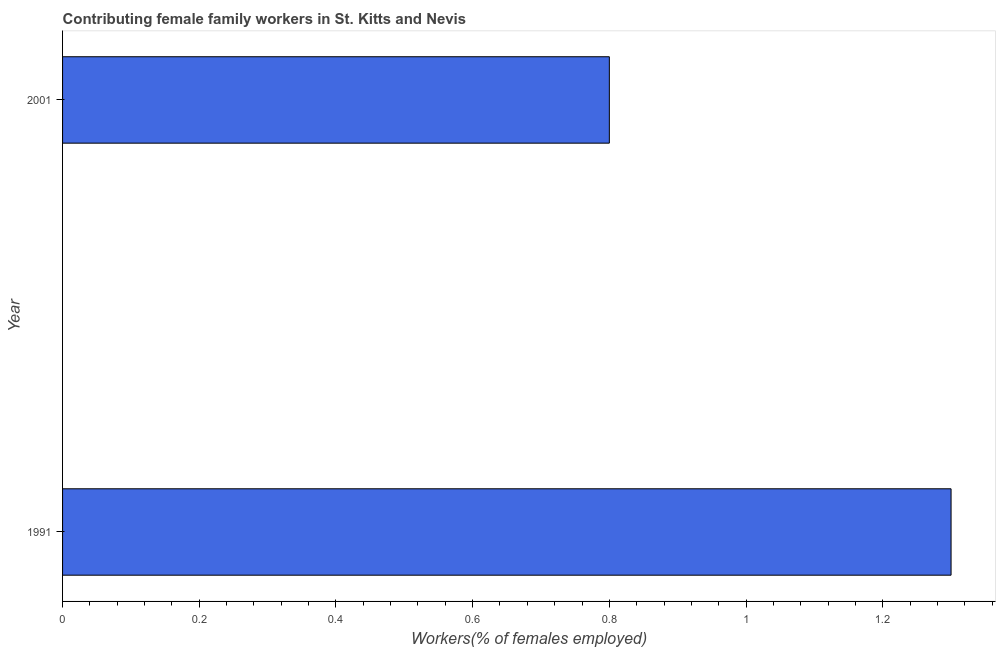Does the graph contain any zero values?
Provide a short and direct response. No. Does the graph contain grids?
Your answer should be very brief. No. What is the title of the graph?
Keep it short and to the point. Contributing female family workers in St. Kitts and Nevis. What is the label or title of the X-axis?
Your response must be concise. Workers(% of females employed). What is the contributing female family workers in 2001?
Your answer should be very brief. 0.8. Across all years, what is the maximum contributing female family workers?
Offer a very short reply. 1.3. Across all years, what is the minimum contributing female family workers?
Make the answer very short. 0.8. What is the sum of the contributing female family workers?
Provide a succinct answer. 2.1. What is the median contributing female family workers?
Your answer should be compact. 1.05. In how many years, is the contributing female family workers greater than 0.24 %?
Keep it short and to the point. 2. What is the ratio of the contributing female family workers in 1991 to that in 2001?
Your response must be concise. 1.62. Is the contributing female family workers in 1991 less than that in 2001?
Your answer should be compact. No. In how many years, is the contributing female family workers greater than the average contributing female family workers taken over all years?
Your answer should be very brief. 1. Are all the bars in the graph horizontal?
Provide a succinct answer. Yes. How many years are there in the graph?
Offer a very short reply. 2. Are the values on the major ticks of X-axis written in scientific E-notation?
Offer a very short reply. No. What is the Workers(% of females employed) in 1991?
Ensure brevity in your answer.  1.3. What is the Workers(% of females employed) in 2001?
Keep it short and to the point. 0.8. What is the ratio of the Workers(% of females employed) in 1991 to that in 2001?
Provide a short and direct response. 1.62. 